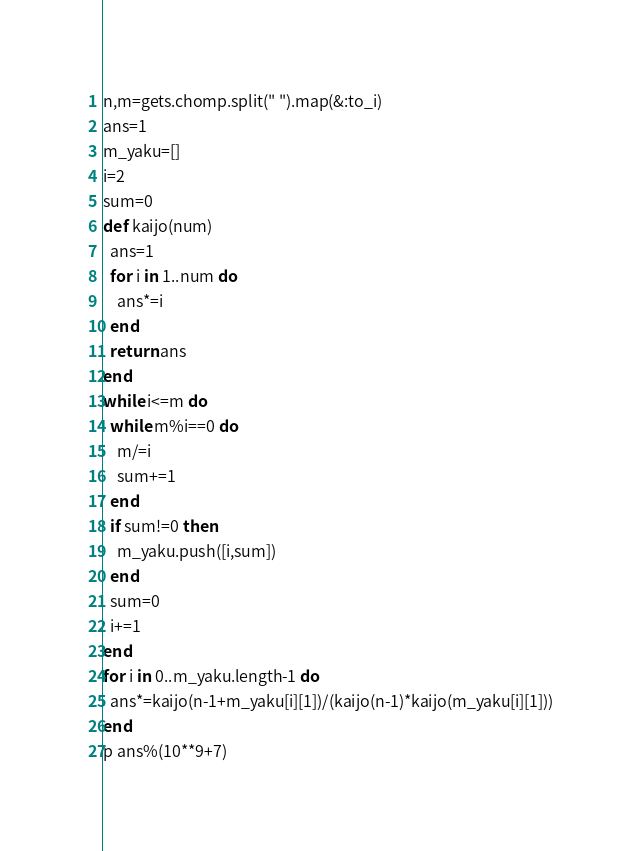Convert code to text. <code><loc_0><loc_0><loc_500><loc_500><_Ruby_>n,m=gets.chomp.split(" ").map(&:to_i)
ans=1
m_yaku=[]
i=2
sum=0
def kaijo(num)
  ans=1
  for i in 1..num do
    ans*=i
  end
  return ans
end
while i<=m do
  while m%i==0 do
    m/=i
    sum+=1
  end
  if sum!=0 then
    m_yaku.push([i,sum])
  end
  sum=0
  i+=1
end
for i in 0..m_yaku.length-1 do
  ans*=kaijo(n-1+m_yaku[i][1])/(kaijo(n-1)*kaijo(m_yaku[i][1]))
end
p ans%(10**9+7)</code> 